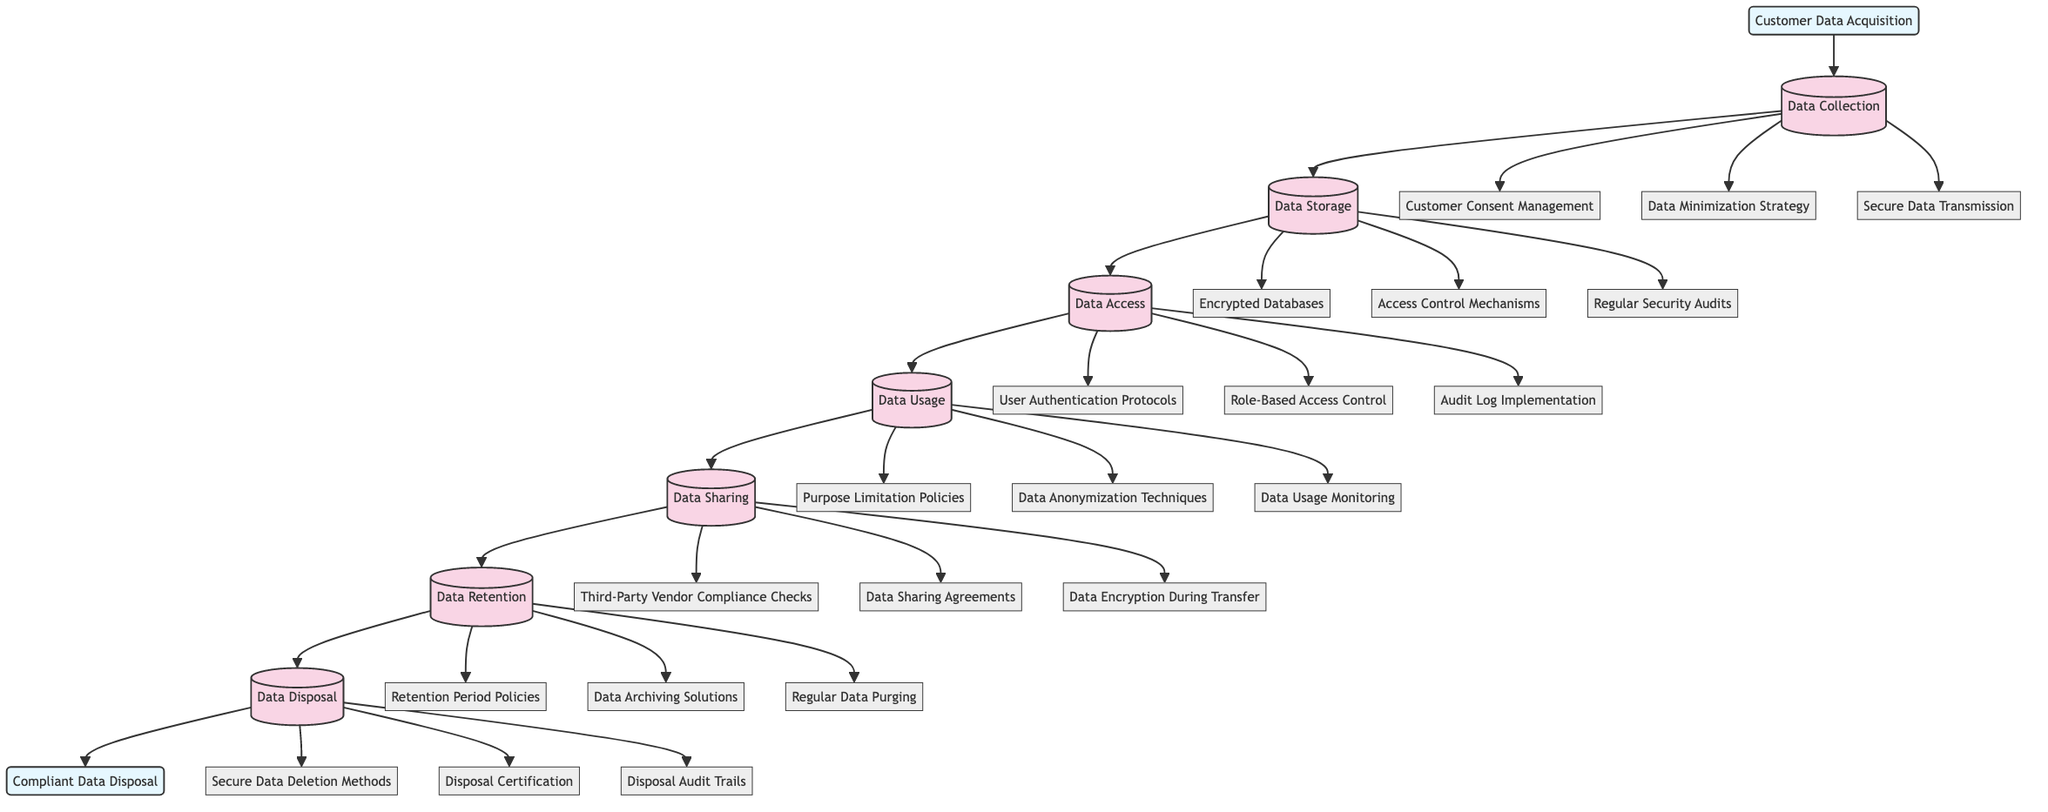What is the starting point of the clinical pathway? The diagram indicates that the starting point of the clinical pathway is labeled as "Customer Data Acquisition."
Answer: Customer Data Acquisition How many steps are there in the clinical pathway? By counting the steps listed in the diagram, there are a total of seven processes from Data Collection to Data Disposal.
Answer: Seven What is the final process before compliant data disposal? The last step before reaching the end node, "Compliant Data Disposal," is "Data Disposal."
Answer: Data Disposal What are the components of the "Data Access" step? The "Data Access" process is associated with three components: "User Authentication Protocols," "Role-Based Access Control," and "Audit Log Implementation."
Answer: User Authentication Protocols, Role-Based Access Control, Audit Log Implementation What is the purpose of the "Data Retention" step? In the flow, the "Data Retention" step includes practices to manage how long customer data is kept, ensuring compliance with policies like "Retention Period Policies."
Answer: Retention Period Policies Which component is part of the "Data Sharing" process? The diagram highlights multiple components under the "Data Sharing" process, including "Third-Party Vendor Compliance Checks."
Answer: Third-Party Vendor Compliance Checks What security measure is included in the "Data Storage" process? This step emphasizes security through the use of "Encrypted Databases," which are crucial for protecting stored customer data.
Answer: Encrypted Databases What step immediately follows "Data Usage"? The clinical pathway indicates that "Data Sharing" follows the "Data Usage" step in the sequence of processes.
Answer: Data Sharing 